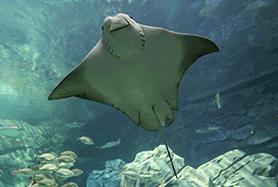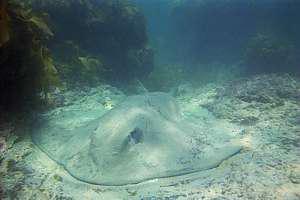The first image is the image on the left, the second image is the image on the right. For the images shown, is this caption "All of the stingrays are laying on the ocean floor." true? Answer yes or no. No. The first image is the image on the left, the second image is the image on the right. Given the left and right images, does the statement "The left image shows a Stingray swimming through the water." hold true? Answer yes or no. Yes. 